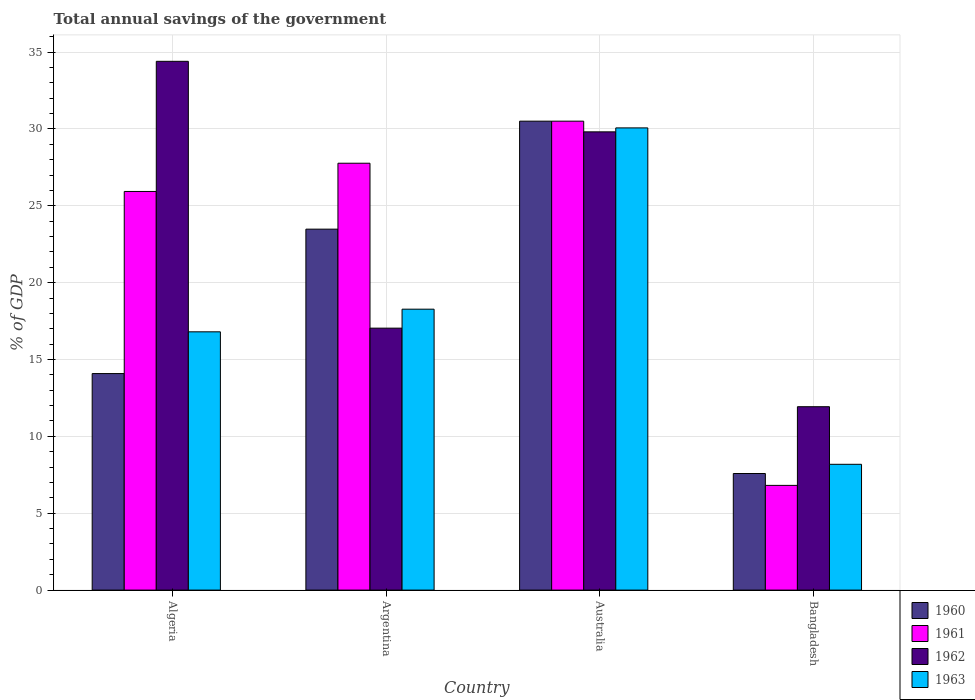Are the number of bars on each tick of the X-axis equal?
Keep it short and to the point. Yes. How many bars are there on the 2nd tick from the right?
Your response must be concise. 4. In how many cases, is the number of bars for a given country not equal to the number of legend labels?
Your response must be concise. 0. What is the total annual savings of the government in 1960 in Australia?
Offer a very short reply. 30.5. Across all countries, what is the maximum total annual savings of the government in 1962?
Give a very brief answer. 34.4. Across all countries, what is the minimum total annual savings of the government in 1961?
Make the answer very short. 6.81. In which country was the total annual savings of the government in 1960 maximum?
Ensure brevity in your answer.  Australia. What is the total total annual savings of the government in 1962 in the graph?
Provide a succinct answer. 93.17. What is the difference between the total annual savings of the government in 1960 in Algeria and that in Australia?
Provide a short and direct response. -16.42. What is the difference between the total annual savings of the government in 1960 in Algeria and the total annual savings of the government in 1962 in Bangladesh?
Offer a very short reply. 2.16. What is the average total annual savings of the government in 1963 per country?
Your answer should be compact. 18.33. What is the difference between the total annual savings of the government of/in 1963 and total annual savings of the government of/in 1961 in Algeria?
Offer a very short reply. -9.13. In how many countries, is the total annual savings of the government in 1960 greater than 8 %?
Make the answer very short. 3. What is the ratio of the total annual savings of the government in 1960 in Argentina to that in Bangladesh?
Your answer should be compact. 3.1. What is the difference between the highest and the second highest total annual savings of the government in 1960?
Make the answer very short. -16.42. What is the difference between the highest and the lowest total annual savings of the government in 1963?
Offer a terse response. 21.88. In how many countries, is the total annual savings of the government in 1960 greater than the average total annual savings of the government in 1960 taken over all countries?
Your answer should be compact. 2. Is the sum of the total annual savings of the government in 1963 in Algeria and Bangladesh greater than the maximum total annual savings of the government in 1962 across all countries?
Ensure brevity in your answer.  No. Is it the case that in every country, the sum of the total annual savings of the government in 1963 and total annual savings of the government in 1961 is greater than the sum of total annual savings of the government in 1962 and total annual savings of the government in 1960?
Ensure brevity in your answer.  No. How many bars are there?
Give a very brief answer. 16. Are all the bars in the graph horizontal?
Offer a very short reply. No. What is the difference between two consecutive major ticks on the Y-axis?
Your answer should be compact. 5. Are the values on the major ticks of Y-axis written in scientific E-notation?
Your response must be concise. No. Does the graph contain any zero values?
Offer a very short reply. No. How many legend labels are there?
Offer a terse response. 4. How are the legend labels stacked?
Your answer should be compact. Vertical. What is the title of the graph?
Make the answer very short. Total annual savings of the government. What is the label or title of the Y-axis?
Make the answer very short. % of GDP. What is the % of GDP of 1960 in Algeria?
Make the answer very short. 14.08. What is the % of GDP of 1961 in Algeria?
Your answer should be very brief. 25.93. What is the % of GDP in 1962 in Algeria?
Give a very brief answer. 34.4. What is the % of GDP of 1963 in Algeria?
Offer a very short reply. 16.8. What is the % of GDP in 1960 in Argentina?
Offer a very short reply. 23.48. What is the % of GDP of 1961 in Argentina?
Your answer should be very brief. 27.77. What is the % of GDP in 1962 in Argentina?
Offer a terse response. 17.04. What is the % of GDP in 1963 in Argentina?
Your answer should be compact. 18.27. What is the % of GDP of 1960 in Australia?
Ensure brevity in your answer.  30.5. What is the % of GDP in 1961 in Australia?
Your answer should be compact. 30.5. What is the % of GDP of 1962 in Australia?
Offer a terse response. 29.81. What is the % of GDP of 1963 in Australia?
Offer a very short reply. 30.07. What is the % of GDP of 1960 in Bangladesh?
Your answer should be compact. 7.58. What is the % of GDP of 1961 in Bangladesh?
Provide a short and direct response. 6.81. What is the % of GDP of 1962 in Bangladesh?
Give a very brief answer. 11.93. What is the % of GDP in 1963 in Bangladesh?
Your response must be concise. 8.18. Across all countries, what is the maximum % of GDP in 1960?
Your response must be concise. 30.5. Across all countries, what is the maximum % of GDP of 1961?
Offer a terse response. 30.5. Across all countries, what is the maximum % of GDP in 1962?
Ensure brevity in your answer.  34.4. Across all countries, what is the maximum % of GDP of 1963?
Make the answer very short. 30.07. Across all countries, what is the minimum % of GDP in 1960?
Give a very brief answer. 7.58. Across all countries, what is the minimum % of GDP in 1961?
Offer a very short reply. 6.81. Across all countries, what is the minimum % of GDP of 1962?
Offer a terse response. 11.93. Across all countries, what is the minimum % of GDP in 1963?
Your response must be concise. 8.18. What is the total % of GDP in 1960 in the graph?
Your answer should be very brief. 75.65. What is the total % of GDP of 1961 in the graph?
Your answer should be compact. 91.01. What is the total % of GDP of 1962 in the graph?
Provide a short and direct response. 93.17. What is the total % of GDP in 1963 in the graph?
Your answer should be very brief. 73.32. What is the difference between the % of GDP of 1960 in Algeria and that in Argentina?
Your answer should be compact. -9.4. What is the difference between the % of GDP of 1961 in Algeria and that in Argentina?
Your response must be concise. -1.84. What is the difference between the % of GDP of 1962 in Algeria and that in Argentina?
Provide a short and direct response. 17.36. What is the difference between the % of GDP in 1963 in Algeria and that in Argentina?
Make the answer very short. -1.47. What is the difference between the % of GDP of 1960 in Algeria and that in Australia?
Your response must be concise. -16.42. What is the difference between the % of GDP of 1961 in Algeria and that in Australia?
Offer a terse response. -4.57. What is the difference between the % of GDP in 1962 in Algeria and that in Australia?
Offer a terse response. 4.59. What is the difference between the % of GDP of 1963 in Algeria and that in Australia?
Offer a terse response. -13.27. What is the difference between the % of GDP of 1960 in Algeria and that in Bangladesh?
Ensure brevity in your answer.  6.5. What is the difference between the % of GDP in 1961 in Algeria and that in Bangladesh?
Keep it short and to the point. 19.12. What is the difference between the % of GDP in 1962 in Algeria and that in Bangladesh?
Make the answer very short. 22.47. What is the difference between the % of GDP of 1963 in Algeria and that in Bangladesh?
Give a very brief answer. 8.62. What is the difference between the % of GDP in 1960 in Argentina and that in Australia?
Your answer should be compact. -7.02. What is the difference between the % of GDP of 1961 in Argentina and that in Australia?
Your answer should be very brief. -2.74. What is the difference between the % of GDP in 1962 in Argentina and that in Australia?
Your response must be concise. -12.77. What is the difference between the % of GDP of 1963 in Argentina and that in Australia?
Offer a terse response. -11.79. What is the difference between the % of GDP of 1960 in Argentina and that in Bangladesh?
Your answer should be very brief. 15.9. What is the difference between the % of GDP of 1961 in Argentina and that in Bangladesh?
Offer a terse response. 20.95. What is the difference between the % of GDP of 1962 in Argentina and that in Bangladesh?
Provide a succinct answer. 5.11. What is the difference between the % of GDP in 1963 in Argentina and that in Bangladesh?
Your answer should be compact. 10.09. What is the difference between the % of GDP of 1960 in Australia and that in Bangladesh?
Provide a succinct answer. 22.92. What is the difference between the % of GDP in 1961 in Australia and that in Bangladesh?
Ensure brevity in your answer.  23.69. What is the difference between the % of GDP in 1962 in Australia and that in Bangladesh?
Your answer should be compact. 17.88. What is the difference between the % of GDP of 1963 in Australia and that in Bangladesh?
Make the answer very short. 21.88. What is the difference between the % of GDP in 1960 in Algeria and the % of GDP in 1961 in Argentina?
Make the answer very short. -13.68. What is the difference between the % of GDP of 1960 in Algeria and the % of GDP of 1962 in Argentina?
Your answer should be compact. -2.96. What is the difference between the % of GDP in 1960 in Algeria and the % of GDP in 1963 in Argentina?
Offer a terse response. -4.19. What is the difference between the % of GDP in 1961 in Algeria and the % of GDP in 1962 in Argentina?
Give a very brief answer. 8.89. What is the difference between the % of GDP of 1961 in Algeria and the % of GDP of 1963 in Argentina?
Give a very brief answer. 7.66. What is the difference between the % of GDP in 1962 in Algeria and the % of GDP in 1963 in Argentina?
Offer a terse response. 16.12. What is the difference between the % of GDP of 1960 in Algeria and the % of GDP of 1961 in Australia?
Make the answer very short. -16.42. What is the difference between the % of GDP in 1960 in Algeria and the % of GDP in 1962 in Australia?
Give a very brief answer. -15.72. What is the difference between the % of GDP of 1960 in Algeria and the % of GDP of 1963 in Australia?
Ensure brevity in your answer.  -15.98. What is the difference between the % of GDP in 1961 in Algeria and the % of GDP in 1962 in Australia?
Provide a succinct answer. -3.88. What is the difference between the % of GDP of 1961 in Algeria and the % of GDP of 1963 in Australia?
Make the answer very short. -4.13. What is the difference between the % of GDP of 1962 in Algeria and the % of GDP of 1963 in Australia?
Your answer should be compact. 4.33. What is the difference between the % of GDP in 1960 in Algeria and the % of GDP in 1961 in Bangladesh?
Offer a terse response. 7.27. What is the difference between the % of GDP in 1960 in Algeria and the % of GDP in 1962 in Bangladesh?
Your answer should be compact. 2.16. What is the difference between the % of GDP of 1960 in Algeria and the % of GDP of 1963 in Bangladesh?
Give a very brief answer. 5.9. What is the difference between the % of GDP of 1961 in Algeria and the % of GDP of 1962 in Bangladesh?
Provide a short and direct response. 14. What is the difference between the % of GDP in 1961 in Algeria and the % of GDP in 1963 in Bangladesh?
Offer a terse response. 17.75. What is the difference between the % of GDP in 1962 in Algeria and the % of GDP in 1963 in Bangladesh?
Keep it short and to the point. 26.21. What is the difference between the % of GDP in 1960 in Argentina and the % of GDP in 1961 in Australia?
Your response must be concise. -7.02. What is the difference between the % of GDP in 1960 in Argentina and the % of GDP in 1962 in Australia?
Give a very brief answer. -6.33. What is the difference between the % of GDP in 1960 in Argentina and the % of GDP in 1963 in Australia?
Provide a short and direct response. -6.59. What is the difference between the % of GDP in 1961 in Argentina and the % of GDP in 1962 in Australia?
Your response must be concise. -2.04. What is the difference between the % of GDP of 1961 in Argentina and the % of GDP of 1963 in Australia?
Your answer should be very brief. -2.3. What is the difference between the % of GDP in 1962 in Argentina and the % of GDP in 1963 in Australia?
Ensure brevity in your answer.  -13.03. What is the difference between the % of GDP of 1960 in Argentina and the % of GDP of 1961 in Bangladesh?
Your response must be concise. 16.67. What is the difference between the % of GDP in 1960 in Argentina and the % of GDP in 1962 in Bangladesh?
Make the answer very short. 11.55. What is the difference between the % of GDP of 1960 in Argentina and the % of GDP of 1963 in Bangladesh?
Give a very brief answer. 15.3. What is the difference between the % of GDP of 1961 in Argentina and the % of GDP of 1962 in Bangladesh?
Provide a succinct answer. 15.84. What is the difference between the % of GDP of 1961 in Argentina and the % of GDP of 1963 in Bangladesh?
Provide a short and direct response. 19.58. What is the difference between the % of GDP in 1962 in Argentina and the % of GDP in 1963 in Bangladesh?
Offer a terse response. 8.86. What is the difference between the % of GDP in 1960 in Australia and the % of GDP in 1961 in Bangladesh?
Your response must be concise. 23.69. What is the difference between the % of GDP in 1960 in Australia and the % of GDP in 1962 in Bangladesh?
Offer a very short reply. 18.57. What is the difference between the % of GDP of 1960 in Australia and the % of GDP of 1963 in Bangladesh?
Offer a terse response. 22.32. What is the difference between the % of GDP of 1961 in Australia and the % of GDP of 1962 in Bangladesh?
Ensure brevity in your answer.  18.57. What is the difference between the % of GDP of 1961 in Australia and the % of GDP of 1963 in Bangladesh?
Ensure brevity in your answer.  22.32. What is the difference between the % of GDP of 1962 in Australia and the % of GDP of 1963 in Bangladesh?
Ensure brevity in your answer.  21.62. What is the average % of GDP in 1960 per country?
Your answer should be compact. 18.91. What is the average % of GDP of 1961 per country?
Provide a succinct answer. 22.75. What is the average % of GDP in 1962 per country?
Your answer should be very brief. 23.29. What is the average % of GDP in 1963 per country?
Your answer should be compact. 18.33. What is the difference between the % of GDP in 1960 and % of GDP in 1961 in Algeria?
Keep it short and to the point. -11.85. What is the difference between the % of GDP of 1960 and % of GDP of 1962 in Algeria?
Your answer should be compact. -20.31. What is the difference between the % of GDP of 1960 and % of GDP of 1963 in Algeria?
Ensure brevity in your answer.  -2.72. What is the difference between the % of GDP in 1961 and % of GDP in 1962 in Algeria?
Make the answer very short. -8.47. What is the difference between the % of GDP in 1961 and % of GDP in 1963 in Algeria?
Keep it short and to the point. 9.13. What is the difference between the % of GDP in 1962 and % of GDP in 1963 in Algeria?
Provide a succinct answer. 17.6. What is the difference between the % of GDP in 1960 and % of GDP in 1961 in Argentina?
Your response must be concise. -4.29. What is the difference between the % of GDP in 1960 and % of GDP in 1962 in Argentina?
Give a very brief answer. 6.44. What is the difference between the % of GDP in 1960 and % of GDP in 1963 in Argentina?
Give a very brief answer. 5.21. What is the difference between the % of GDP of 1961 and % of GDP of 1962 in Argentina?
Offer a terse response. 10.73. What is the difference between the % of GDP of 1961 and % of GDP of 1963 in Argentina?
Ensure brevity in your answer.  9.49. What is the difference between the % of GDP of 1962 and % of GDP of 1963 in Argentina?
Your response must be concise. -1.23. What is the difference between the % of GDP in 1960 and % of GDP in 1961 in Australia?
Give a very brief answer. -0. What is the difference between the % of GDP in 1960 and % of GDP in 1962 in Australia?
Keep it short and to the point. 0.7. What is the difference between the % of GDP in 1960 and % of GDP in 1963 in Australia?
Give a very brief answer. 0.44. What is the difference between the % of GDP of 1961 and % of GDP of 1962 in Australia?
Offer a very short reply. 0.7. What is the difference between the % of GDP in 1961 and % of GDP in 1963 in Australia?
Offer a very short reply. 0.44. What is the difference between the % of GDP in 1962 and % of GDP in 1963 in Australia?
Your answer should be compact. -0.26. What is the difference between the % of GDP of 1960 and % of GDP of 1961 in Bangladesh?
Your answer should be very brief. 0.77. What is the difference between the % of GDP in 1960 and % of GDP in 1962 in Bangladesh?
Offer a terse response. -4.35. What is the difference between the % of GDP in 1960 and % of GDP in 1963 in Bangladesh?
Keep it short and to the point. -0.6. What is the difference between the % of GDP of 1961 and % of GDP of 1962 in Bangladesh?
Your response must be concise. -5.12. What is the difference between the % of GDP of 1961 and % of GDP of 1963 in Bangladesh?
Offer a very short reply. -1.37. What is the difference between the % of GDP of 1962 and % of GDP of 1963 in Bangladesh?
Provide a short and direct response. 3.75. What is the ratio of the % of GDP in 1960 in Algeria to that in Argentina?
Offer a very short reply. 0.6. What is the ratio of the % of GDP of 1961 in Algeria to that in Argentina?
Your response must be concise. 0.93. What is the ratio of the % of GDP in 1962 in Algeria to that in Argentina?
Provide a short and direct response. 2.02. What is the ratio of the % of GDP in 1963 in Algeria to that in Argentina?
Your answer should be compact. 0.92. What is the ratio of the % of GDP in 1960 in Algeria to that in Australia?
Offer a very short reply. 0.46. What is the ratio of the % of GDP of 1961 in Algeria to that in Australia?
Make the answer very short. 0.85. What is the ratio of the % of GDP in 1962 in Algeria to that in Australia?
Provide a succinct answer. 1.15. What is the ratio of the % of GDP of 1963 in Algeria to that in Australia?
Make the answer very short. 0.56. What is the ratio of the % of GDP in 1960 in Algeria to that in Bangladesh?
Offer a very short reply. 1.86. What is the ratio of the % of GDP of 1961 in Algeria to that in Bangladesh?
Your answer should be very brief. 3.81. What is the ratio of the % of GDP in 1962 in Algeria to that in Bangladesh?
Your answer should be compact. 2.88. What is the ratio of the % of GDP in 1963 in Algeria to that in Bangladesh?
Your answer should be very brief. 2.05. What is the ratio of the % of GDP of 1960 in Argentina to that in Australia?
Offer a terse response. 0.77. What is the ratio of the % of GDP in 1961 in Argentina to that in Australia?
Give a very brief answer. 0.91. What is the ratio of the % of GDP of 1962 in Argentina to that in Australia?
Provide a succinct answer. 0.57. What is the ratio of the % of GDP of 1963 in Argentina to that in Australia?
Your answer should be very brief. 0.61. What is the ratio of the % of GDP of 1960 in Argentina to that in Bangladesh?
Ensure brevity in your answer.  3.1. What is the ratio of the % of GDP of 1961 in Argentina to that in Bangladesh?
Ensure brevity in your answer.  4.08. What is the ratio of the % of GDP in 1962 in Argentina to that in Bangladesh?
Your answer should be very brief. 1.43. What is the ratio of the % of GDP in 1963 in Argentina to that in Bangladesh?
Ensure brevity in your answer.  2.23. What is the ratio of the % of GDP in 1960 in Australia to that in Bangladesh?
Your answer should be compact. 4.02. What is the ratio of the % of GDP in 1961 in Australia to that in Bangladesh?
Your answer should be very brief. 4.48. What is the ratio of the % of GDP in 1962 in Australia to that in Bangladesh?
Ensure brevity in your answer.  2.5. What is the ratio of the % of GDP of 1963 in Australia to that in Bangladesh?
Give a very brief answer. 3.67. What is the difference between the highest and the second highest % of GDP in 1960?
Your response must be concise. 7.02. What is the difference between the highest and the second highest % of GDP in 1961?
Make the answer very short. 2.74. What is the difference between the highest and the second highest % of GDP of 1962?
Keep it short and to the point. 4.59. What is the difference between the highest and the second highest % of GDP in 1963?
Give a very brief answer. 11.79. What is the difference between the highest and the lowest % of GDP in 1960?
Your answer should be compact. 22.92. What is the difference between the highest and the lowest % of GDP of 1961?
Your response must be concise. 23.69. What is the difference between the highest and the lowest % of GDP in 1962?
Offer a very short reply. 22.47. What is the difference between the highest and the lowest % of GDP in 1963?
Ensure brevity in your answer.  21.88. 